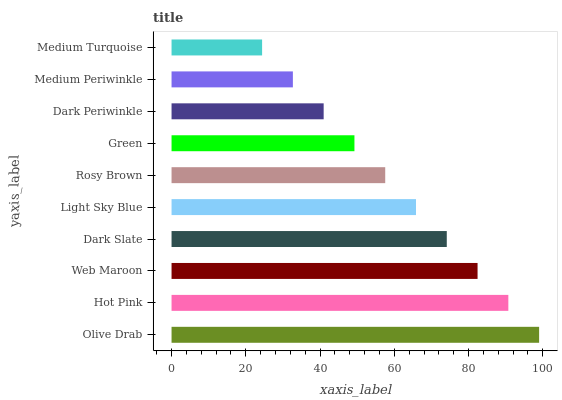Is Medium Turquoise the minimum?
Answer yes or no. Yes. Is Olive Drab the maximum?
Answer yes or no. Yes. Is Hot Pink the minimum?
Answer yes or no. No. Is Hot Pink the maximum?
Answer yes or no. No. Is Olive Drab greater than Hot Pink?
Answer yes or no. Yes. Is Hot Pink less than Olive Drab?
Answer yes or no. Yes. Is Hot Pink greater than Olive Drab?
Answer yes or no. No. Is Olive Drab less than Hot Pink?
Answer yes or no. No. Is Light Sky Blue the high median?
Answer yes or no. Yes. Is Rosy Brown the low median?
Answer yes or no. Yes. Is Hot Pink the high median?
Answer yes or no. No. Is Olive Drab the low median?
Answer yes or no. No. 